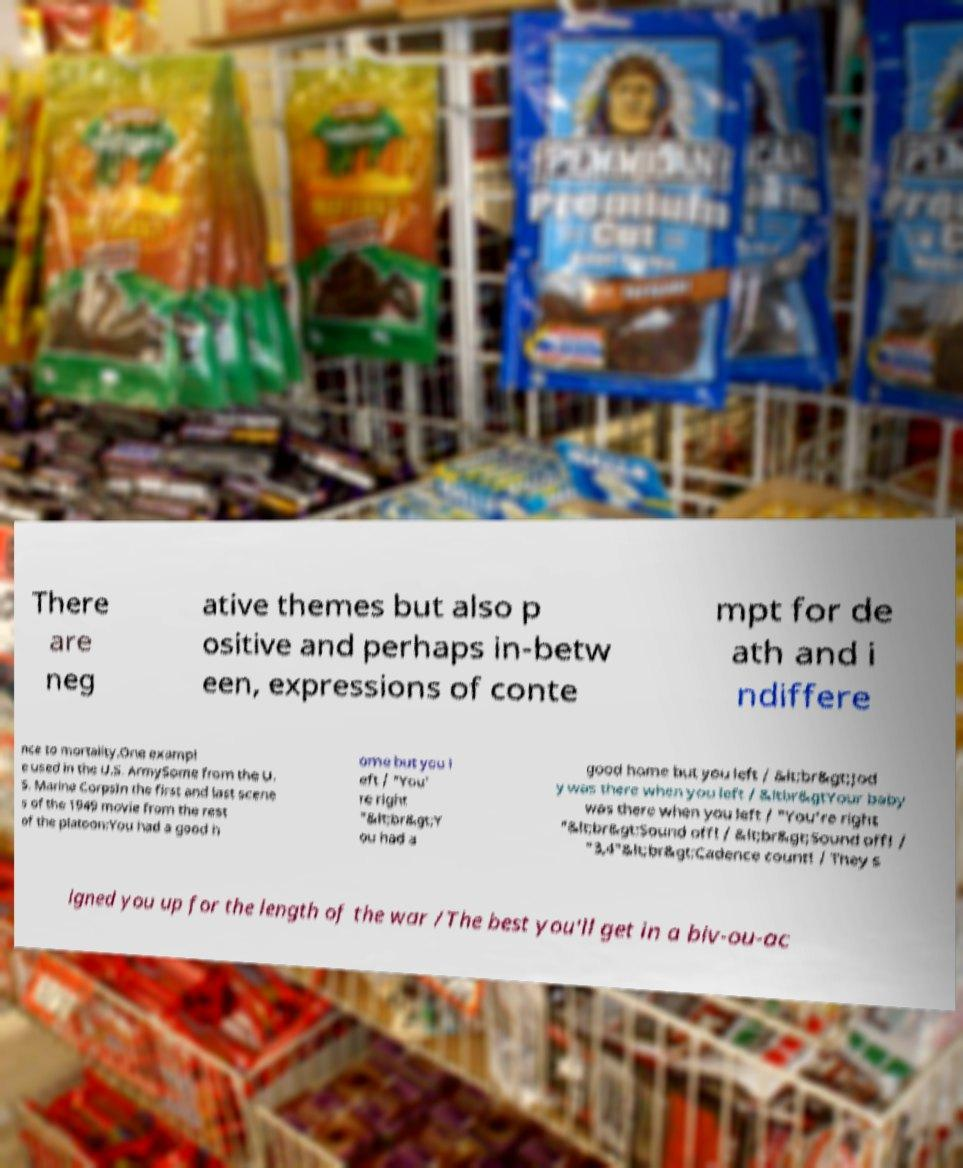For documentation purposes, I need the text within this image transcribed. Could you provide that? There are neg ative themes but also p ositive and perhaps in-betw een, expressions of conte mpt for de ath and i ndiffere nce to mortality.One exampl e used in the U.S. ArmySome from the U. S. Marine CorpsIn the first and last scene s of the 1949 movie from the rest of the platoon:You had a good h ome but you l eft / "You' re right "&lt;br&gt;Y ou had a good home but you left / &lt;br&gt;Jod y was there when you left / &ltbr&gtYour baby was there when you left / "You're right "&lt;br&gt;Sound off! / &lt;br&gt;Sound off! / "3,4"&lt;br&gt;Cadence count! / They s igned you up for the length of the war /The best you'll get in a biv-ou-ac 